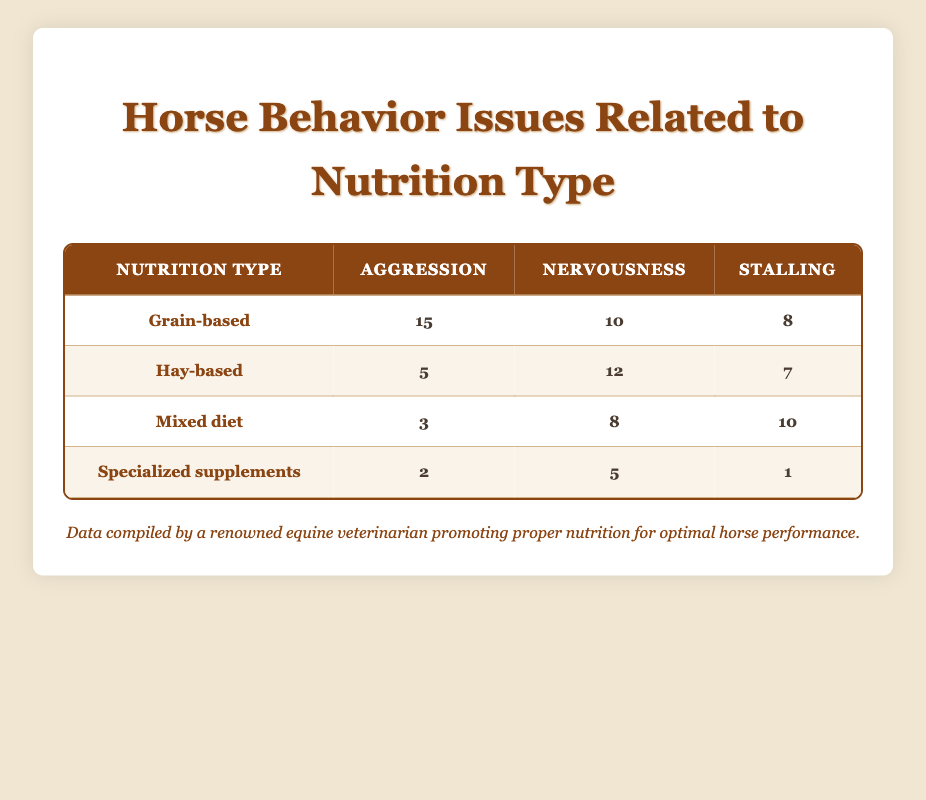What is the highest reported aggression issue among horses? Looking at the table, the highest count for aggression is 15, reported for the Grain-based nutrition type.
Answer: 15 How many behavior issues have been reported for hay-based nutrition in total? To find the total for hay-based nutrition, we add the counts for aggression (5), nervousness (12), and stalling (7): 5 + 12 + 7 = 24.
Answer: 24 Is there any nutrition type that has reported zero aggression issues? The count for aggression issues in Mixed diet (3) and Specialized supplements (2) both are greater than zero, so all nutrition types have reported aggression issues.
Answer: No Which nutrition type has the fewest reported cases of stalling? From the table, Specialized supplements have 1 case of stalling, which is the lowest compared to the other types.
Answer: Specialized supplements What is the mean number of reported nervousness issues across all nutrition types? The counts of nervousness are 10 (Grain-based), 12 (Hay-based), 8 (Mixed diet), and 5 (Specialized supplements). Adding these gives 10 + 12 + 8 + 5 = 35. Then divide by the number of nutrition types (4): 35 / 4 = 8.75.
Answer: 8.75 How does the stalling behavior issue for Mixed diet compare to the stalling behavior issue for Hay-based nutrition? The stalling issue count is 10 for Mixed diet and 7 for Hay-based. Since 10 > 7, the Mixed diet has more stalling issues.
Answer: Mixed diet has more stalling issues Which type of nutrition has the highest total of all behavior issues combined? Adding the counts for each nutrition type: Grain-based (15 + 10 + 8 = 33), Hay-based (5 + 12 + 7 = 24), Mixed diet (3 + 8 + 10 = 21), Specialized supplements (2 + 5 + 1 = 8). The highest total is for Grain-based with 33.
Answer: Grain-based Does the table indicate that horses on a grain-based diet have a higher tendency for nervousness compared to those on a mixed diet? The grain-based diet reports 10 instances of nervousness compared to 8 in the mixed diet, thus indicating a higher tendency for nervousness.
Answer: Yes Which nutrition type has the highest count for aggression compared to its other behavior issues? For Grain-based, aggression is 15, while nervousness is 10 and stalling is 8. In the other types, aggression doesn't exceed these values. Therefore, Grain-based has the highest for aggression.
Answer: Grain-based 